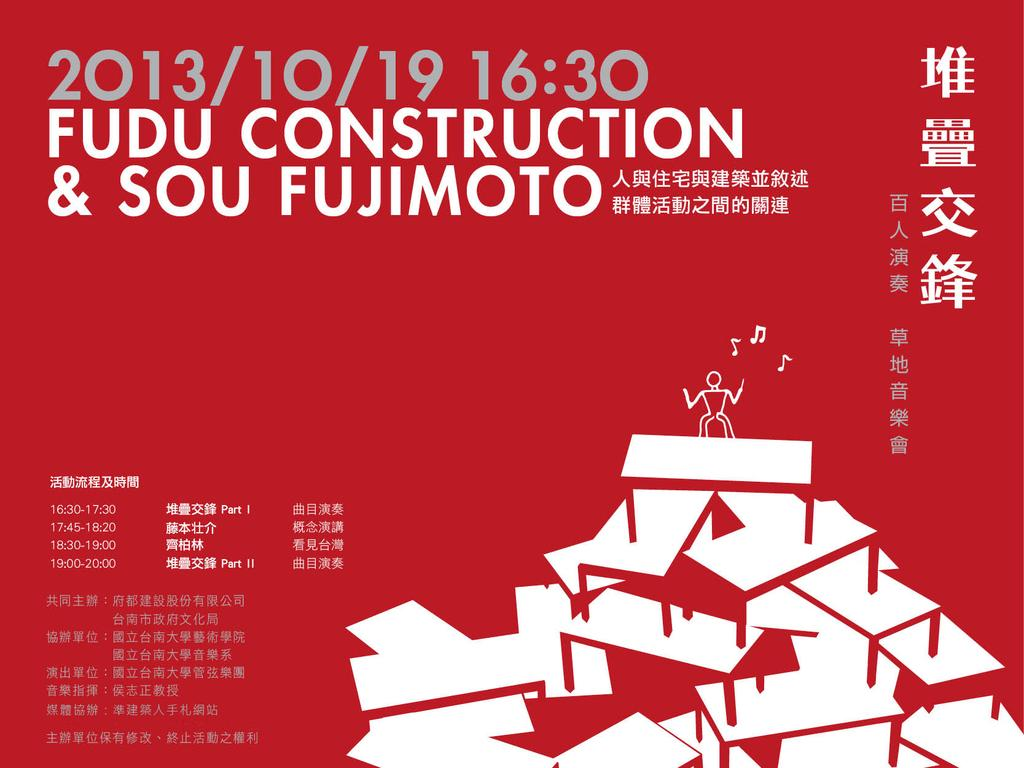<image>
Provide a brief description of the given image. An asian poster for Fudu Construction in 2013. 